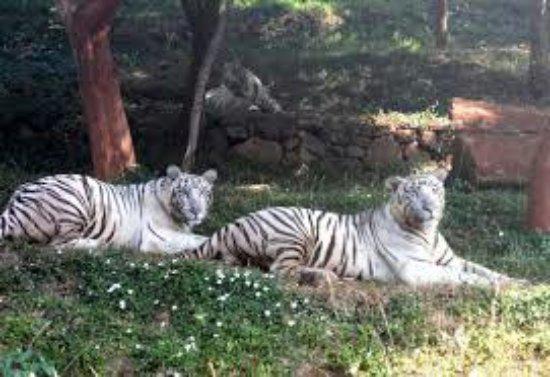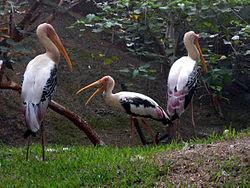The first image is the image on the left, the second image is the image on the right. Considering the images on both sides, is "The animals in one of the images have horns." valid? Answer yes or no. No. 